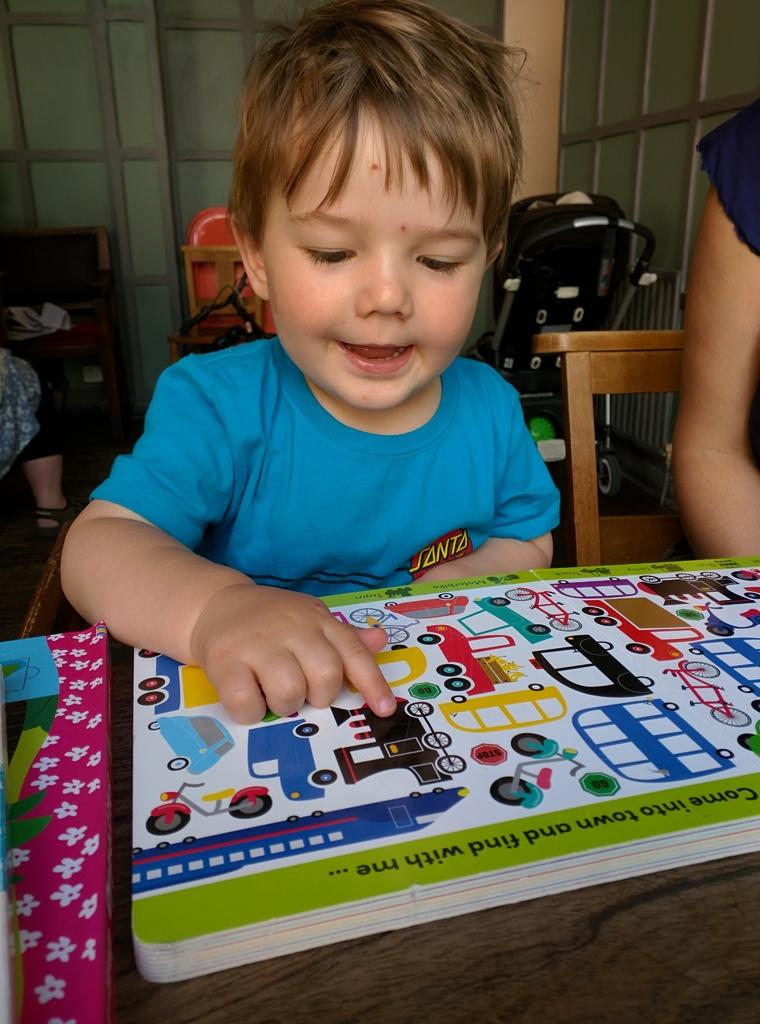Who is the main subject in the picture? There is a boy in the picture. What is the boy doing in the picture? The boy is smiling and looking at pictures in a book. Where is the book located? The book is on a table. What type of glove is the boy wearing in the picture? There is no glove visible in the picture; the boy is not wearing any gloves. 